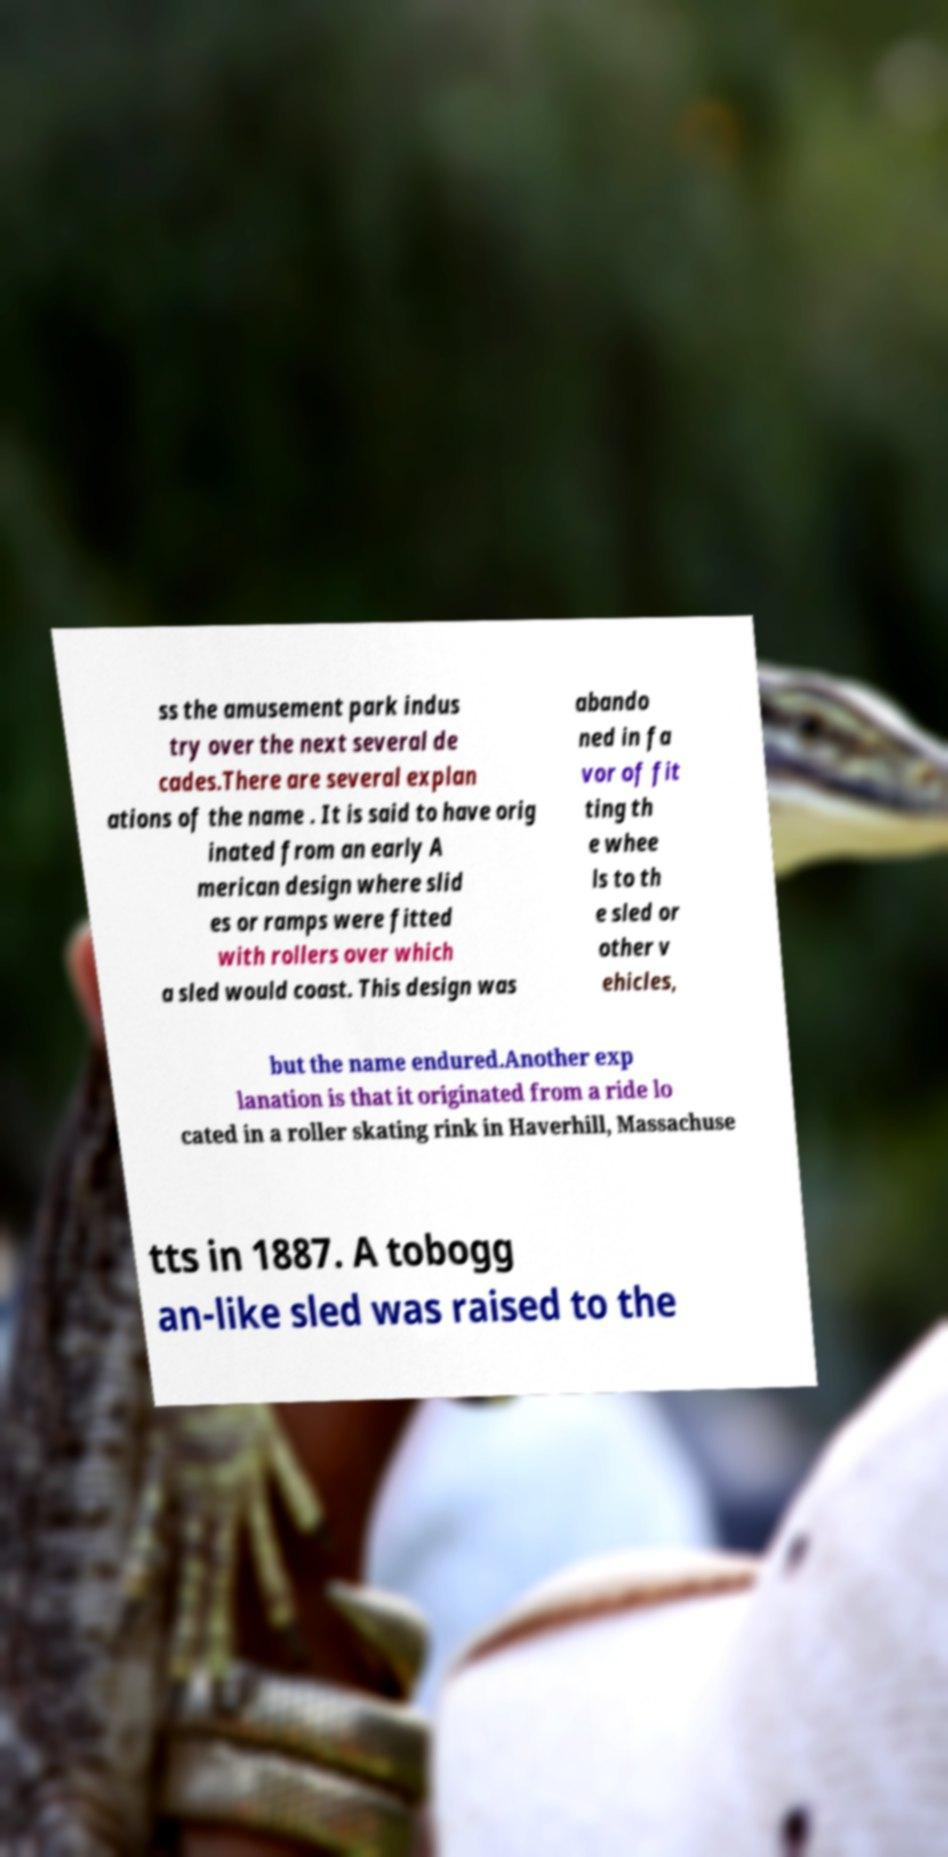For documentation purposes, I need the text within this image transcribed. Could you provide that? ss the amusement park indus try over the next several de cades.There are several explan ations of the name . It is said to have orig inated from an early A merican design where slid es or ramps were fitted with rollers over which a sled would coast. This design was abando ned in fa vor of fit ting th e whee ls to th e sled or other v ehicles, but the name endured.Another exp lanation is that it originated from a ride lo cated in a roller skating rink in Haverhill, Massachuse tts in 1887. A tobogg an-like sled was raised to the 